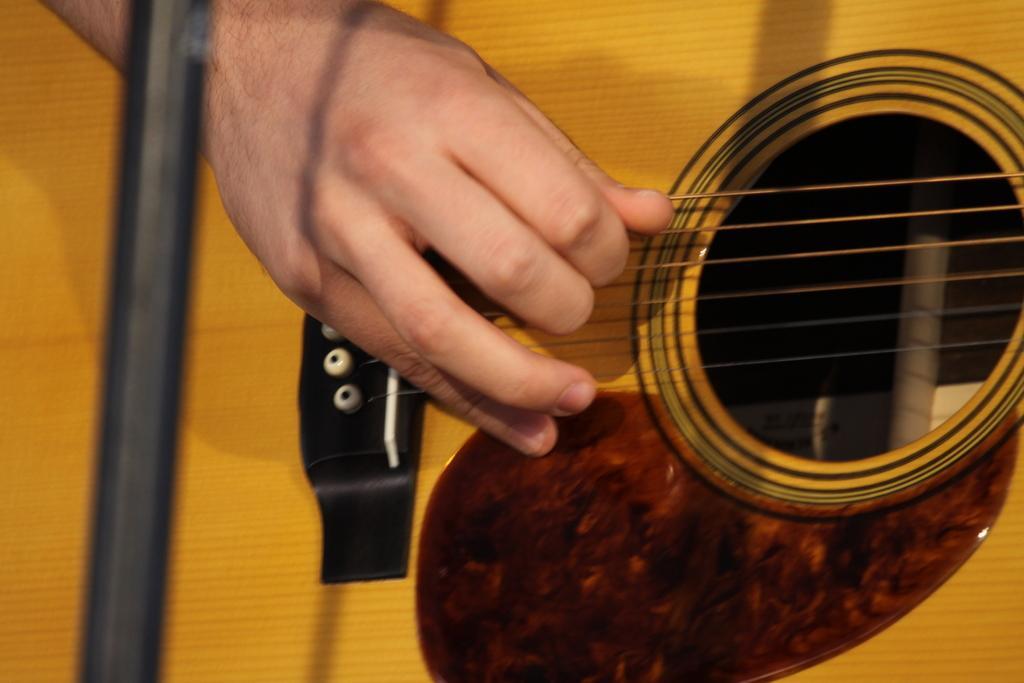Could you give a brief overview of what you see in this image? There is a hand on the guitar. The person is playing a guitar. 